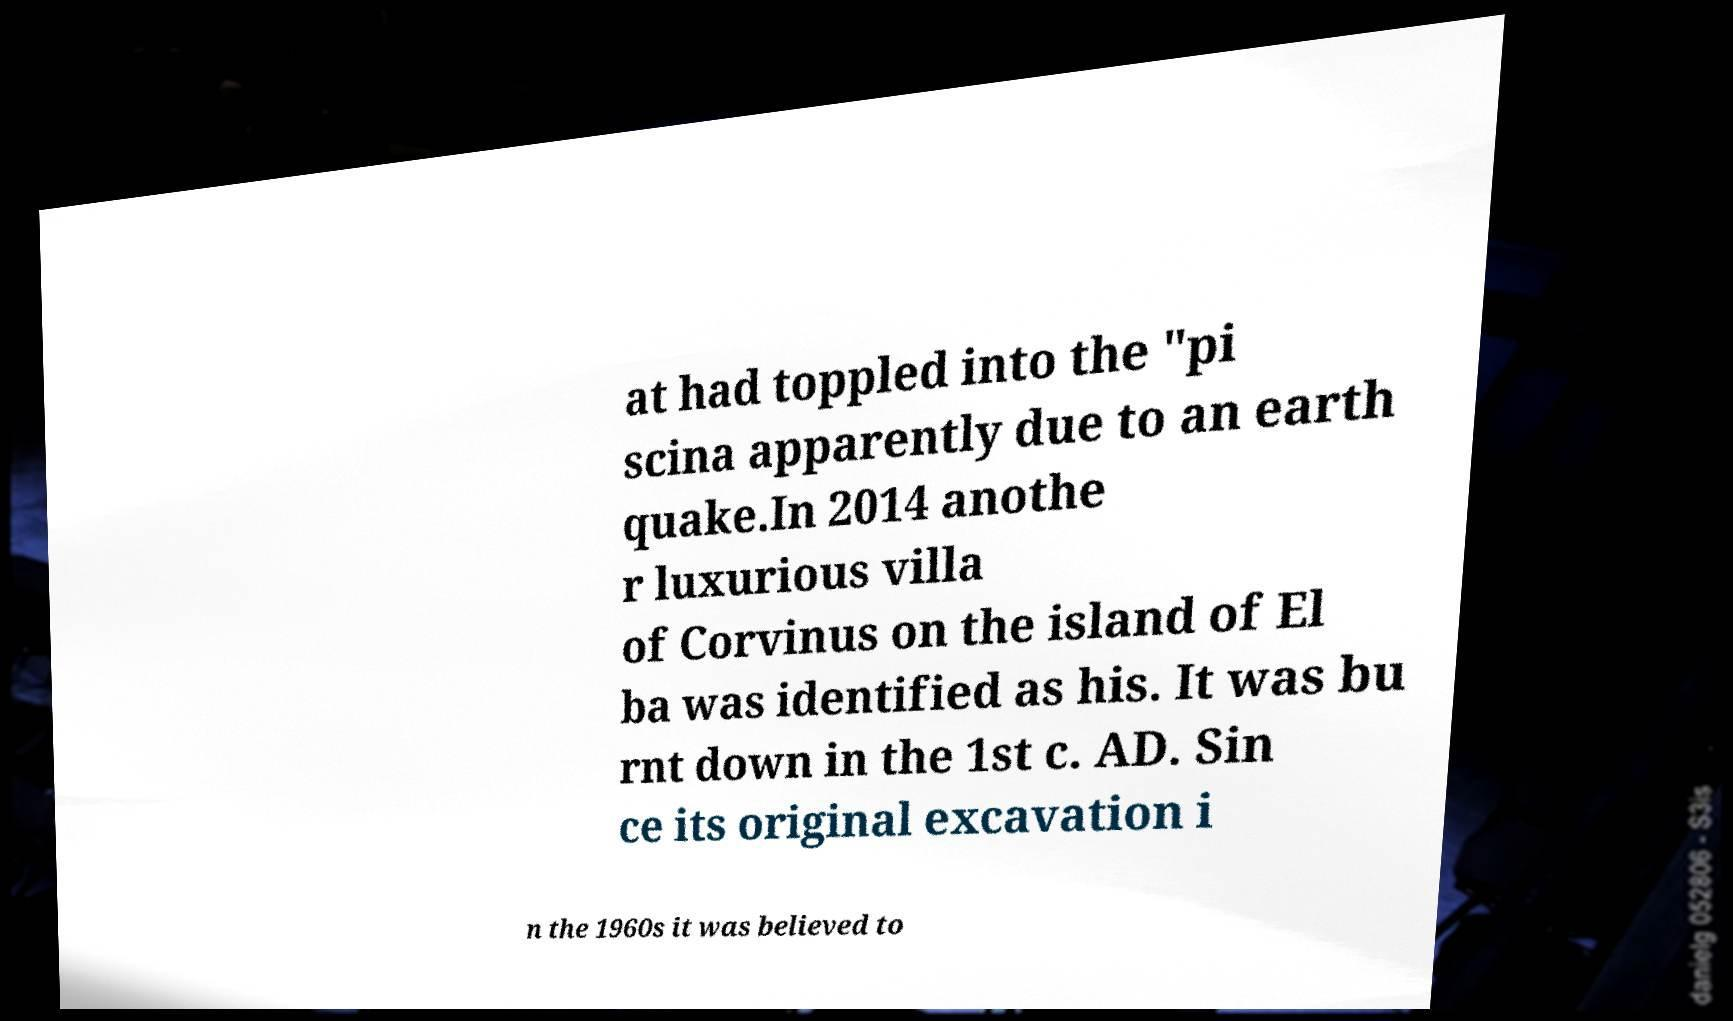Can you read and provide the text displayed in the image?This photo seems to have some interesting text. Can you extract and type it out for me? at had toppled into the "pi scina apparently due to an earth quake.In 2014 anothe r luxurious villa of Corvinus on the island of El ba was identified as his. It was bu rnt down in the 1st c. AD. Sin ce its original excavation i n the 1960s it was believed to 